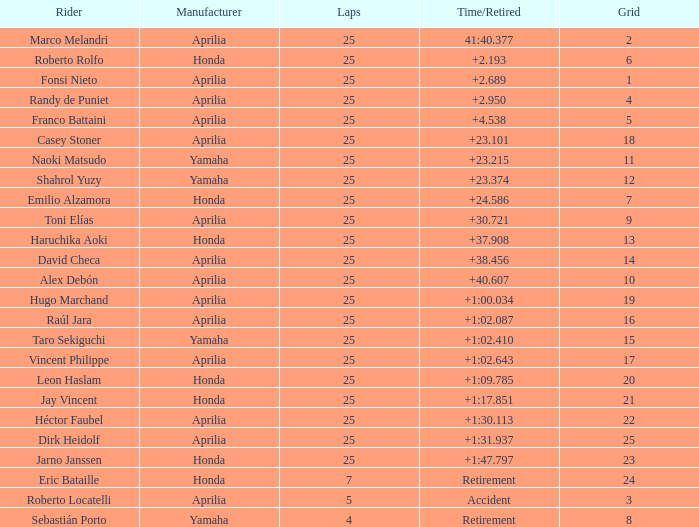Which Grid has Laps of 25, and a Manufacturer of honda, and a Time/Retired of +1:47.797? 23.0. 